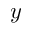Convert formula to latex. <formula><loc_0><loc_0><loc_500><loc_500>y</formula> 